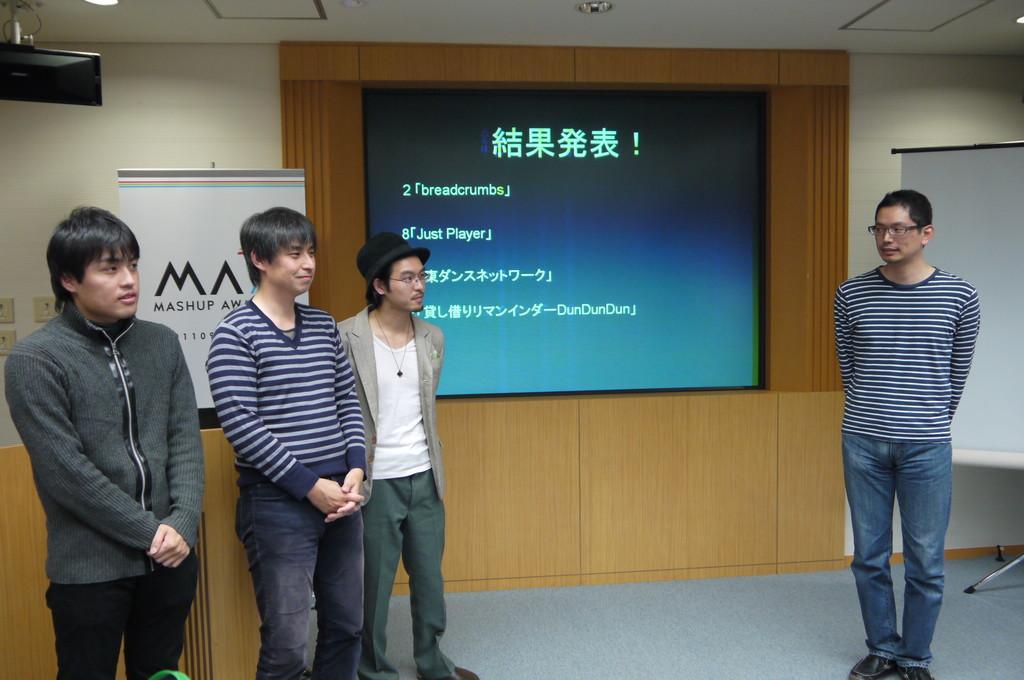Describe this image in one or two sentences. In this picture we can see the some boys standing in the hall. On the right side there is boy wearing white and blue color stripe t-shirt. standing in the front. Behind there is a the projector screen. On the left side we can see a white color roller banner. In the background there is a wooden panel wall. 